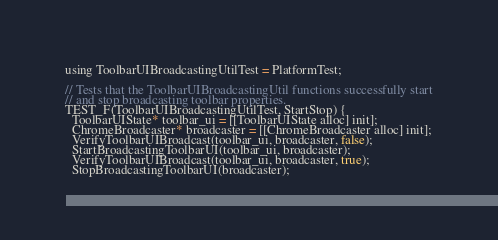Convert code to text. <code><loc_0><loc_0><loc_500><loc_500><_ObjectiveC_>using ToolbarUIBroadcastingUtilTest = PlatformTest;

// Tests that the ToolbarUIBroadcastingUtil functions successfully start
// and stop broadcasting toolbar properties.
TEST_F(ToolbarUIBroadcastingUtilTest, StartStop) {
  ToolbarUIState* toolbar_ui = [[ToolbarUIState alloc] init];
  ChromeBroadcaster* broadcaster = [[ChromeBroadcaster alloc] init];
  VerifyToolbarUIBroadcast(toolbar_ui, broadcaster, false);
  StartBroadcastingToolbarUI(toolbar_ui, broadcaster);
  VerifyToolbarUIBroadcast(toolbar_ui, broadcaster, true);
  StopBroadcastingToolbarUI(broadcaster);</code> 